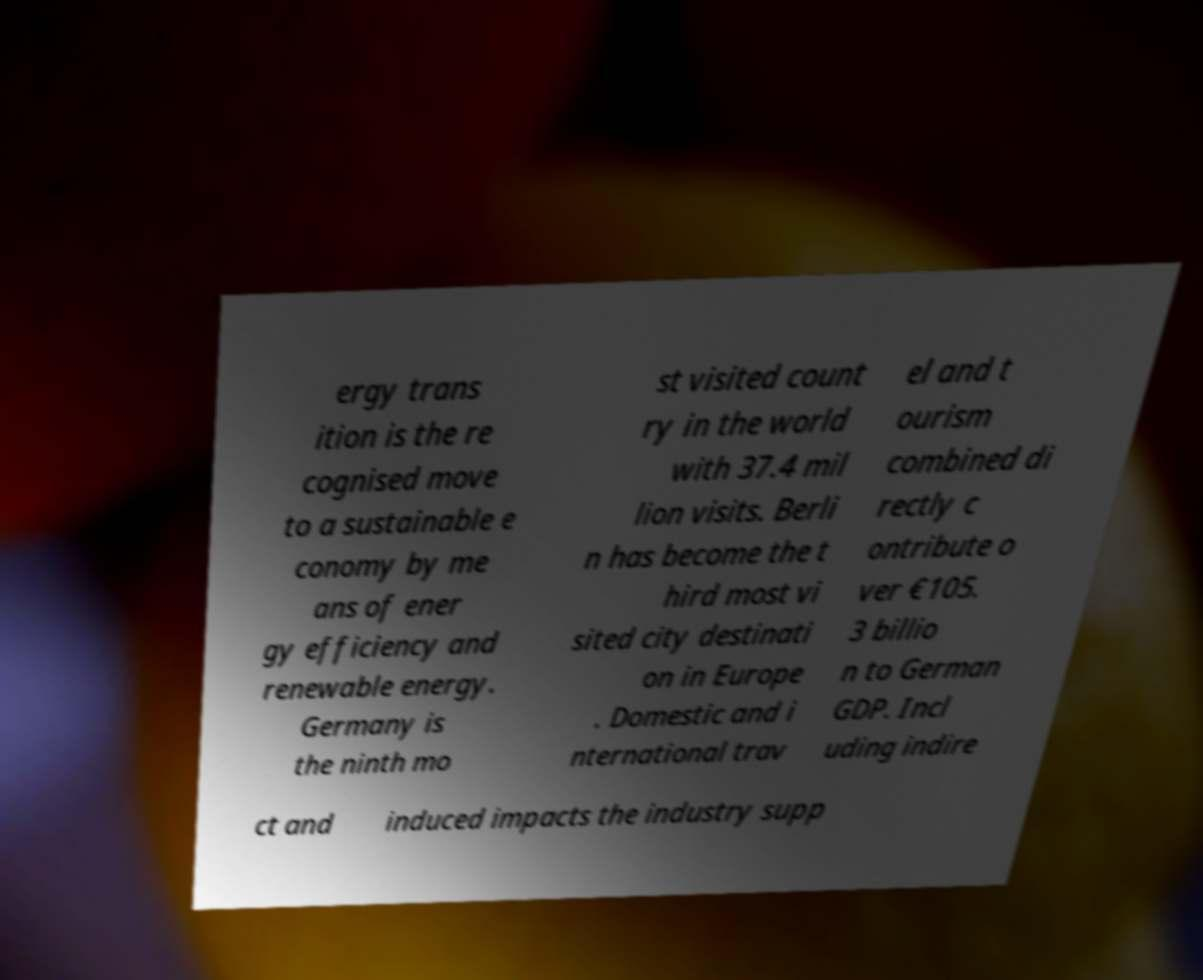Please read and relay the text visible in this image. What does it say? ergy trans ition is the re cognised move to a sustainable e conomy by me ans of ener gy efficiency and renewable energy. Germany is the ninth mo st visited count ry in the world with 37.4 mil lion visits. Berli n has become the t hird most vi sited city destinati on in Europe . Domestic and i nternational trav el and t ourism combined di rectly c ontribute o ver €105. 3 billio n to German GDP. Incl uding indire ct and induced impacts the industry supp 